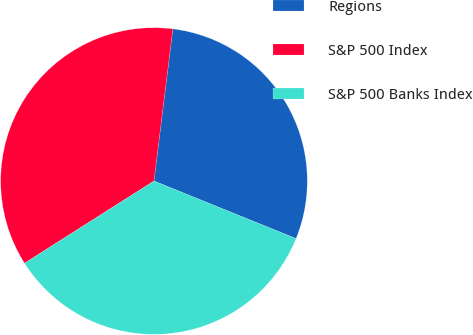Convert chart. <chart><loc_0><loc_0><loc_500><loc_500><pie_chart><fcel>Regions<fcel>S&P 500 Index<fcel>S&P 500 Banks Index<nl><fcel>29.16%<fcel>35.97%<fcel>34.87%<nl></chart> 